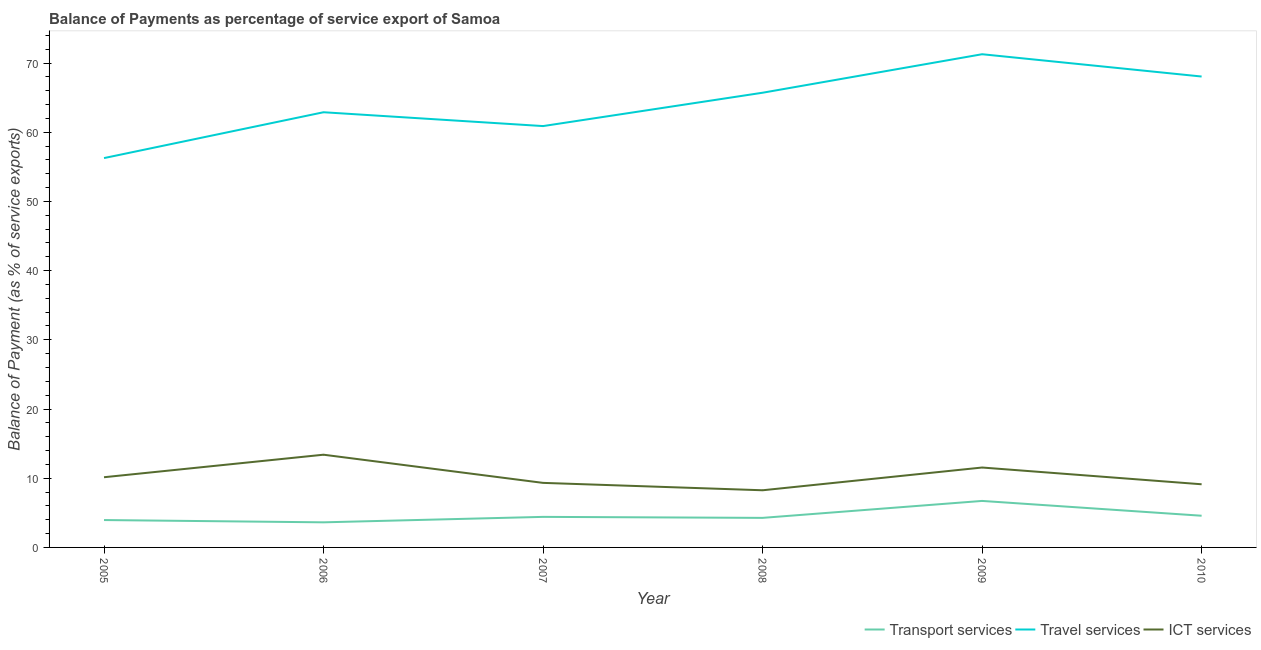Does the line corresponding to balance of payment of transport services intersect with the line corresponding to balance of payment of travel services?
Make the answer very short. No. What is the balance of payment of travel services in 2008?
Your response must be concise. 65.71. Across all years, what is the maximum balance of payment of transport services?
Give a very brief answer. 6.72. Across all years, what is the minimum balance of payment of ict services?
Ensure brevity in your answer.  8.26. In which year was the balance of payment of transport services maximum?
Provide a short and direct response. 2009. In which year was the balance of payment of transport services minimum?
Provide a succinct answer. 2006. What is the total balance of payment of travel services in the graph?
Provide a succinct answer. 385.05. What is the difference between the balance of payment of ict services in 2008 and that in 2010?
Your answer should be compact. -0.87. What is the difference between the balance of payment of travel services in 2010 and the balance of payment of transport services in 2009?
Provide a short and direct response. 61.33. What is the average balance of payment of transport services per year?
Provide a succinct answer. 4.59. In the year 2006, what is the difference between the balance of payment of ict services and balance of payment of travel services?
Give a very brief answer. -49.49. What is the ratio of the balance of payment of ict services in 2008 to that in 2009?
Offer a terse response. 0.72. What is the difference between the highest and the second highest balance of payment of travel services?
Give a very brief answer. 3.22. What is the difference between the highest and the lowest balance of payment of transport services?
Your answer should be compact. 3.09. In how many years, is the balance of payment of ict services greater than the average balance of payment of ict services taken over all years?
Provide a short and direct response. 2. Is the sum of the balance of payment of transport services in 2006 and 2009 greater than the maximum balance of payment of travel services across all years?
Keep it short and to the point. No. Is it the case that in every year, the sum of the balance of payment of transport services and balance of payment of travel services is greater than the balance of payment of ict services?
Your response must be concise. Yes. Does the balance of payment of transport services monotonically increase over the years?
Make the answer very short. No. Is the balance of payment of travel services strictly less than the balance of payment of ict services over the years?
Your answer should be very brief. No. How many lines are there?
Provide a short and direct response. 3. Are the values on the major ticks of Y-axis written in scientific E-notation?
Give a very brief answer. No. What is the title of the graph?
Your answer should be compact. Balance of Payments as percentage of service export of Samoa. What is the label or title of the Y-axis?
Provide a succinct answer. Balance of Payment (as % of service exports). What is the Balance of Payment (as % of service exports) of Transport services in 2005?
Provide a short and direct response. 3.96. What is the Balance of Payment (as % of service exports) of Travel services in 2005?
Your response must be concise. 56.26. What is the Balance of Payment (as % of service exports) in ICT services in 2005?
Make the answer very short. 10.14. What is the Balance of Payment (as % of service exports) in Transport services in 2006?
Offer a terse response. 3.63. What is the Balance of Payment (as % of service exports) of Travel services in 2006?
Your answer should be very brief. 62.88. What is the Balance of Payment (as % of service exports) of ICT services in 2006?
Offer a very short reply. 13.4. What is the Balance of Payment (as % of service exports) of Transport services in 2007?
Your answer should be compact. 4.41. What is the Balance of Payment (as % of service exports) in Travel services in 2007?
Your response must be concise. 60.89. What is the Balance of Payment (as % of service exports) in ICT services in 2007?
Your answer should be very brief. 9.33. What is the Balance of Payment (as % of service exports) of Transport services in 2008?
Provide a succinct answer. 4.27. What is the Balance of Payment (as % of service exports) of Travel services in 2008?
Offer a terse response. 65.71. What is the Balance of Payment (as % of service exports) in ICT services in 2008?
Provide a short and direct response. 8.26. What is the Balance of Payment (as % of service exports) of Transport services in 2009?
Give a very brief answer. 6.72. What is the Balance of Payment (as % of service exports) of Travel services in 2009?
Provide a succinct answer. 71.27. What is the Balance of Payment (as % of service exports) of ICT services in 2009?
Your response must be concise. 11.55. What is the Balance of Payment (as % of service exports) of Transport services in 2010?
Provide a short and direct response. 4.58. What is the Balance of Payment (as % of service exports) of Travel services in 2010?
Provide a succinct answer. 68.05. What is the Balance of Payment (as % of service exports) in ICT services in 2010?
Provide a succinct answer. 9.13. Across all years, what is the maximum Balance of Payment (as % of service exports) of Transport services?
Your response must be concise. 6.72. Across all years, what is the maximum Balance of Payment (as % of service exports) of Travel services?
Give a very brief answer. 71.27. Across all years, what is the maximum Balance of Payment (as % of service exports) of ICT services?
Your answer should be very brief. 13.4. Across all years, what is the minimum Balance of Payment (as % of service exports) in Transport services?
Ensure brevity in your answer.  3.63. Across all years, what is the minimum Balance of Payment (as % of service exports) in Travel services?
Your response must be concise. 56.26. Across all years, what is the minimum Balance of Payment (as % of service exports) of ICT services?
Your answer should be compact. 8.26. What is the total Balance of Payment (as % of service exports) of Transport services in the graph?
Provide a short and direct response. 27.57. What is the total Balance of Payment (as % of service exports) of Travel services in the graph?
Offer a very short reply. 385.05. What is the total Balance of Payment (as % of service exports) in ICT services in the graph?
Offer a terse response. 61.8. What is the difference between the Balance of Payment (as % of service exports) of Transport services in 2005 and that in 2006?
Your answer should be very brief. 0.33. What is the difference between the Balance of Payment (as % of service exports) of Travel services in 2005 and that in 2006?
Make the answer very short. -6.62. What is the difference between the Balance of Payment (as % of service exports) in ICT services in 2005 and that in 2006?
Your answer should be very brief. -3.25. What is the difference between the Balance of Payment (as % of service exports) in Transport services in 2005 and that in 2007?
Keep it short and to the point. -0.46. What is the difference between the Balance of Payment (as % of service exports) in Travel services in 2005 and that in 2007?
Provide a succinct answer. -4.63. What is the difference between the Balance of Payment (as % of service exports) of ICT services in 2005 and that in 2007?
Your answer should be compact. 0.82. What is the difference between the Balance of Payment (as % of service exports) in Transport services in 2005 and that in 2008?
Offer a terse response. -0.32. What is the difference between the Balance of Payment (as % of service exports) of Travel services in 2005 and that in 2008?
Give a very brief answer. -9.45. What is the difference between the Balance of Payment (as % of service exports) of ICT services in 2005 and that in 2008?
Your answer should be compact. 1.88. What is the difference between the Balance of Payment (as % of service exports) of Transport services in 2005 and that in 2009?
Your answer should be very brief. -2.76. What is the difference between the Balance of Payment (as % of service exports) in Travel services in 2005 and that in 2009?
Provide a short and direct response. -15.01. What is the difference between the Balance of Payment (as % of service exports) in ICT services in 2005 and that in 2009?
Ensure brevity in your answer.  -1.4. What is the difference between the Balance of Payment (as % of service exports) of Transport services in 2005 and that in 2010?
Give a very brief answer. -0.62. What is the difference between the Balance of Payment (as % of service exports) of Travel services in 2005 and that in 2010?
Offer a terse response. -11.79. What is the difference between the Balance of Payment (as % of service exports) in ICT services in 2005 and that in 2010?
Give a very brief answer. 1.02. What is the difference between the Balance of Payment (as % of service exports) of Transport services in 2006 and that in 2007?
Your response must be concise. -0.79. What is the difference between the Balance of Payment (as % of service exports) in Travel services in 2006 and that in 2007?
Give a very brief answer. 2. What is the difference between the Balance of Payment (as % of service exports) of ICT services in 2006 and that in 2007?
Offer a terse response. 4.07. What is the difference between the Balance of Payment (as % of service exports) in Transport services in 2006 and that in 2008?
Your answer should be very brief. -0.65. What is the difference between the Balance of Payment (as % of service exports) in Travel services in 2006 and that in 2008?
Provide a short and direct response. -2.82. What is the difference between the Balance of Payment (as % of service exports) of ICT services in 2006 and that in 2008?
Make the answer very short. 5.14. What is the difference between the Balance of Payment (as % of service exports) of Transport services in 2006 and that in 2009?
Your response must be concise. -3.09. What is the difference between the Balance of Payment (as % of service exports) of Travel services in 2006 and that in 2009?
Give a very brief answer. -8.38. What is the difference between the Balance of Payment (as % of service exports) of ICT services in 2006 and that in 2009?
Offer a terse response. 1.85. What is the difference between the Balance of Payment (as % of service exports) in Transport services in 2006 and that in 2010?
Provide a succinct answer. -0.95. What is the difference between the Balance of Payment (as % of service exports) of Travel services in 2006 and that in 2010?
Make the answer very short. -5.16. What is the difference between the Balance of Payment (as % of service exports) in ICT services in 2006 and that in 2010?
Your answer should be very brief. 4.27. What is the difference between the Balance of Payment (as % of service exports) in Transport services in 2007 and that in 2008?
Keep it short and to the point. 0.14. What is the difference between the Balance of Payment (as % of service exports) in Travel services in 2007 and that in 2008?
Ensure brevity in your answer.  -4.82. What is the difference between the Balance of Payment (as % of service exports) of ICT services in 2007 and that in 2008?
Your answer should be very brief. 1.07. What is the difference between the Balance of Payment (as % of service exports) in Transport services in 2007 and that in 2009?
Offer a very short reply. -2.31. What is the difference between the Balance of Payment (as % of service exports) of Travel services in 2007 and that in 2009?
Your answer should be compact. -10.38. What is the difference between the Balance of Payment (as % of service exports) of ICT services in 2007 and that in 2009?
Keep it short and to the point. -2.22. What is the difference between the Balance of Payment (as % of service exports) of Transport services in 2007 and that in 2010?
Provide a succinct answer. -0.17. What is the difference between the Balance of Payment (as % of service exports) in Travel services in 2007 and that in 2010?
Your answer should be very brief. -7.16. What is the difference between the Balance of Payment (as % of service exports) of ICT services in 2007 and that in 2010?
Keep it short and to the point. 0.2. What is the difference between the Balance of Payment (as % of service exports) of Transport services in 2008 and that in 2009?
Offer a very short reply. -2.45. What is the difference between the Balance of Payment (as % of service exports) in Travel services in 2008 and that in 2009?
Your answer should be very brief. -5.56. What is the difference between the Balance of Payment (as % of service exports) of ICT services in 2008 and that in 2009?
Make the answer very short. -3.29. What is the difference between the Balance of Payment (as % of service exports) of Transport services in 2008 and that in 2010?
Provide a short and direct response. -0.31. What is the difference between the Balance of Payment (as % of service exports) of Travel services in 2008 and that in 2010?
Offer a terse response. -2.34. What is the difference between the Balance of Payment (as % of service exports) in ICT services in 2008 and that in 2010?
Provide a succinct answer. -0.87. What is the difference between the Balance of Payment (as % of service exports) in Transport services in 2009 and that in 2010?
Offer a terse response. 2.14. What is the difference between the Balance of Payment (as % of service exports) in Travel services in 2009 and that in 2010?
Your answer should be very brief. 3.22. What is the difference between the Balance of Payment (as % of service exports) in ICT services in 2009 and that in 2010?
Provide a short and direct response. 2.42. What is the difference between the Balance of Payment (as % of service exports) in Transport services in 2005 and the Balance of Payment (as % of service exports) in Travel services in 2006?
Make the answer very short. -58.93. What is the difference between the Balance of Payment (as % of service exports) in Transport services in 2005 and the Balance of Payment (as % of service exports) in ICT services in 2006?
Ensure brevity in your answer.  -9.44. What is the difference between the Balance of Payment (as % of service exports) of Travel services in 2005 and the Balance of Payment (as % of service exports) of ICT services in 2006?
Your answer should be compact. 42.86. What is the difference between the Balance of Payment (as % of service exports) of Transport services in 2005 and the Balance of Payment (as % of service exports) of Travel services in 2007?
Keep it short and to the point. -56.93. What is the difference between the Balance of Payment (as % of service exports) of Transport services in 2005 and the Balance of Payment (as % of service exports) of ICT services in 2007?
Give a very brief answer. -5.37. What is the difference between the Balance of Payment (as % of service exports) of Travel services in 2005 and the Balance of Payment (as % of service exports) of ICT services in 2007?
Your answer should be compact. 46.93. What is the difference between the Balance of Payment (as % of service exports) in Transport services in 2005 and the Balance of Payment (as % of service exports) in Travel services in 2008?
Keep it short and to the point. -61.75. What is the difference between the Balance of Payment (as % of service exports) of Transport services in 2005 and the Balance of Payment (as % of service exports) of ICT services in 2008?
Your answer should be compact. -4.3. What is the difference between the Balance of Payment (as % of service exports) in Travel services in 2005 and the Balance of Payment (as % of service exports) in ICT services in 2008?
Your answer should be compact. 48. What is the difference between the Balance of Payment (as % of service exports) in Transport services in 2005 and the Balance of Payment (as % of service exports) in Travel services in 2009?
Your answer should be very brief. -67.31. What is the difference between the Balance of Payment (as % of service exports) of Transport services in 2005 and the Balance of Payment (as % of service exports) of ICT services in 2009?
Your response must be concise. -7.59. What is the difference between the Balance of Payment (as % of service exports) of Travel services in 2005 and the Balance of Payment (as % of service exports) of ICT services in 2009?
Make the answer very short. 44.71. What is the difference between the Balance of Payment (as % of service exports) of Transport services in 2005 and the Balance of Payment (as % of service exports) of Travel services in 2010?
Offer a terse response. -64.09. What is the difference between the Balance of Payment (as % of service exports) of Transport services in 2005 and the Balance of Payment (as % of service exports) of ICT services in 2010?
Offer a very short reply. -5.17. What is the difference between the Balance of Payment (as % of service exports) in Travel services in 2005 and the Balance of Payment (as % of service exports) in ICT services in 2010?
Give a very brief answer. 47.13. What is the difference between the Balance of Payment (as % of service exports) of Transport services in 2006 and the Balance of Payment (as % of service exports) of Travel services in 2007?
Make the answer very short. -57.26. What is the difference between the Balance of Payment (as % of service exports) in Transport services in 2006 and the Balance of Payment (as % of service exports) in ICT services in 2007?
Ensure brevity in your answer.  -5.7. What is the difference between the Balance of Payment (as % of service exports) in Travel services in 2006 and the Balance of Payment (as % of service exports) in ICT services in 2007?
Offer a very short reply. 53.56. What is the difference between the Balance of Payment (as % of service exports) in Transport services in 2006 and the Balance of Payment (as % of service exports) in Travel services in 2008?
Offer a terse response. -62.08. What is the difference between the Balance of Payment (as % of service exports) of Transport services in 2006 and the Balance of Payment (as % of service exports) of ICT services in 2008?
Your answer should be very brief. -4.63. What is the difference between the Balance of Payment (as % of service exports) in Travel services in 2006 and the Balance of Payment (as % of service exports) in ICT services in 2008?
Your response must be concise. 54.63. What is the difference between the Balance of Payment (as % of service exports) of Transport services in 2006 and the Balance of Payment (as % of service exports) of Travel services in 2009?
Provide a short and direct response. -67.64. What is the difference between the Balance of Payment (as % of service exports) of Transport services in 2006 and the Balance of Payment (as % of service exports) of ICT services in 2009?
Make the answer very short. -7.92. What is the difference between the Balance of Payment (as % of service exports) of Travel services in 2006 and the Balance of Payment (as % of service exports) of ICT services in 2009?
Your answer should be compact. 51.34. What is the difference between the Balance of Payment (as % of service exports) of Transport services in 2006 and the Balance of Payment (as % of service exports) of Travel services in 2010?
Ensure brevity in your answer.  -64.42. What is the difference between the Balance of Payment (as % of service exports) in Transport services in 2006 and the Balance of Payment (as % of service exports) in ICT services in 2010?
Ensure brevity in your answer.  -5.5. What is the difference between the Balance of Payment (as % of service exports) of Travel services in 2006 and the Balance of Payment (as % of service exports) of ICT services in 2010?
Make the answer very short. 53.76. What is the difference between the Balance of Payment (as % of service exports) in Transport services in 2007 and the Balance of Payment (as % of service exports) in Travel services in 2008?
Your answer should be very brief. -61.29. What is the difference between the Balance of Payment (as % of service exports) of Transport services in 2007 and the Balance of Payment (as % of service exports) of ICT services in 2008?
Your response must be concise. -3.85. What is the difference between the Balance of Payment (as % of service exports) of Travel services in 2007 and the Balance of Payment (as % of service exports) of ICT services in 2008?
Offer a very short reply. 52.63. What is the difference between the Balance of Payment (as % of service exports) of Transport services in 2007 and the Balance of Payment (as % of service exports) of Travel services in 2009?
Ensure brevity in your answer.  -66.85. What is the difference between the Balance of Payment (as % of service exports) in Transport services in 2007 and the Balance of Payment (as % of service exports) in ICT services in 2009?
Ensure brevity in your answer.  -7.13. What is the difference between the Balance of Payment (as % of service exports) of Travel services in 2007 and the Balance of Payment (as % of service exports) of ICT services in 2009?
Your answer should be very brief. 49.34. What is the difference between the Balance of Payment (as % of service exports) of Transport services in 2007 and the Balance of Payment (as % of service exports) of Travel services in 2010?
Provide a short and direct response. -63.63. What is the difference between the Balance of Payment (as % of service exports) of Transport services in 2007 and the Balance of Payment (as % of service exports) of ICT services in 2010?
Offer a terse response. -4.71. What is the difference between the Balance of Payment (as % of service exports) of Travel services in 2007 and the Balance of Payment (as % of service exports) of ICT services in 2010?
Your answer should be very brief. 51.76. What is the difference between the Balance of Payment (as % of service exports) in Transport services in 2008 and the Balance of Payment (as % of service exports) in Travel services in 2009?
Ensure brevity in your answer.  -67. What is the difference between the Balance of Payment (as % of service exports) of Transport services in 2008 and the Balance of Payment (as % of service exports) of ICT services in 2009?
Your answer should be compact. -7.28. What is the difference between the Balance of Payment (as % of service exports) in Travel services in 2008 and the Balance of Payment (as % of service exports) in ICT services in 2009?
Provide a succinct answer. 54.16. What is the difference between the Balance of Payment (as % of service exports) of Transport services in 2008 and the Balance of Payment (as % of service exports) of Travel services in 2010?
Give a very brief answer. -63.78. What is the difference between the Balance of Payment (as % of service exports) of Transport services in 2008 and the Balance of Payment (as % of service exports) of ICT services in 2010?
Your response must be concise. -4.85. What is the difference between the Balance of Payment (as % of service exports) of Travel services in 2008 and the Balance of Payment (as % of service exports) of ICT services in 2010?
Offer a terse response. 56.58. What is the difference between the Balance of Payment (as % of service exports) of Transport services in 2009 and the Balance of Payment (as % of service exports) of Travel services in 2010?
Provide a short and direct response. -61.33. What is the difference between the Balance of Payment (as % of service exports) of Transport services in 2009 and the Balance of Payment (as % of service exports) of ICT services in 2010?
Your answer should be very brief. -2.41. What is the difference between the Balance of Payment (as % of service exports) in Travel services in 2009 and the Balance of Payment (as % of service exports) in ICT services in 2010?
Your response must be concise. 62.14. What is the average Balance of Payment (as % of service exports) in Transport services per year?
Offer a very short reply. 4.59. What is the average Balance of Payment (as % of service exports) of Travel services per year?
Provide a short and direct response. 64.18. What is the average Balance of Payment (as % of service exports) of ICT services per year?
Your answer should be very brief. 10.3. In the year 2005, what is the difference between the Balance of Payment (as % of service exports) in Transport services and Balance of Payment (as % of service exports) in Travel services?
Keep it short and to the point. -52.3. In the year 2005, what is the difference between the Balance of Payment (as % of service exports) in Transport services and Balance of Payment (as % of service exports) in ICT services?
Make the answer very short. -6.19. In the year 2005, what is the difference between the Balance of Payment (as % of service exports) of Travel services and Balance of Payment (as % of service exports) of ICT services?
Make the answer very short. 46.12. In the year 2006, what is the difference between the Balance of Payment (as % of service exports) of Transport services and Balance of Payment (as % of service exports) of Travel services?
Keep it short and to the point. -59.26. In the year 2006, what is the difference between the Balance of Payment (as % of service exports) of Transport services and Balance of Payment (as % of service exports) of ICT services?
Provide a short and direct response. -9.77. In the year 2006, what is the difference between the Balance of Payment (as % of service exports) of Travel services and Balance of Payment (as % of service exports) of ICT services?
Keep it short and to the point. 49.49. In the year 2007, what is the difference between the Balance of Payment (as % of service exports) of Transport services and Balance of Payment (as % of service exports) of Travel services?
Your response must be concise. -56.47. In the year 2007, what is the difference between the Balance of Payment (as % of service exports) of Transport services and Balance of Payment (as % of service exports) of ICT services?
Your answer should be very brief. -4.91. In the year 2007, what is the difference between the Balance of Payment (as % of service exports) of Travel services and Balance of Payment (as % of service exports) of ICT services?
Offer a very short reply. 51.56. In the year 2008, what is the difference between the Balance of Payment (as % of service exports) of Transport services and Balance of Payment (as % of service exports) of Travel services?
Your answer should be very brief. -61.43. In the year 2008, what is the difference between the Balance of Payment (as % of service exports) of Transport services and Balance of Payment (as % of service exports) of ICT services?
Make the answer very short. -3.99. In the year 2008, what is the difference between the Balance of Payment (as % of service exports) of Travel services and Balance of Payment (as % of service exports) of ICT services?
Provide a succinct answer. 57.45. In the year 2009, what is the difference between the Balance of Payment (as % of service exports) of Transport services and Balance of Payment (as % of service exports) of Travel services?
Offer a very short reply. -64.55. In the year 2009, what is the difference between the Balance of Payment (as % of service exports) of Transport services and Balance of Payment (as % of service exports) of ICT services?
Provide a succinct answer. -4.83. In the year 2009, what is the difference between the Balance of Payment (as % of service exports) in Travel services and Balance of Payment (as % of service exports) in ICT services?
Give a very brief answer. 59.72. In the year 2010, what is the difference between the Balance of Payment (as % of service exports) of Transport services and Balance of Payment (as % of service exports) of Travel services?
Your response must be concise. -63.47. In the year 2010, what is the difference between the Balance of Payment (as % of service exports) of Transport services and Balance of Payment (as % of service exports) of ICT services?
Give a very brief answer. -4.55. In the year 2010, what is the difference between the Balance of Payment (as % of service exports) of Travel services and Balance of Payment (as % of service exports) of ICT services?
Provide a short and direct response. 58.92. What is the ratio of the Balance of Payment (as % of service exports) of Transport services in 2005 to that in 2006?
Your answer should be very brief. 1.09. What is the ratio of the Balance of Payment (as % of service exports) of Travel services in 2005 to that in 2006?
Keep it short and to the point. 0.89. What is the ratio of the Balance of Payment (as % of service exports) in ICT services in 2005 to that in 2006?
Keep it short and to the point. 0.76. What is the ratio of the Balance of Payment (as % of service exports) of Transport services in 2005 to that in 2007?
Your answer should be compact. 0.9. What is the ratio of the Balance of Payment (as % of service exports) in Travel services in 2005 to that in 2007?
Give a very brief answer. 0.92. What is the ratio of the Balance of Payment (as % of service exports) in ICT services in 2005 to that in 2007?
Ensure brevity in your answer.  1.09. What is the ratio of the Balance of Payment (as % of service exports) of Transport services in 2005 to that in 2008?
Your response must be concise. 0.93. What is the ratio of the Balance of Payment (as % of service exports) in Travel services in 2005 to that in 2008?
Give a very brief answer. 0.86. What is the ratio of the Balance of Payment (as % of service exports) of ICT services in 2005 to that in 2008?
Provide a succinct answer. 1.23. What is the ratio of the Balance of Payment (as % of service exports) of Transport services in 2005 to that in 2009?
Keep it short and to the point. 0.59. What is the ratio of the Balance of Payment (as % of service exports) of Travel services in 2005 to that in 2009?
Offer a very short reply. 0.79. What is the ratio of the Balance of Payment (as % of service exports) of ICT services in 2005 to that in 2009?
Your answer should be compact. 0.88. What is the ratio of the Balance of Payment (as % of service exports) of Transport services in 2005 to that in 2010?
Offer a terse response. 0.86. What is the ratio of the Balance of Payment (as % of service exports) of Travel services in 2005 to that in 2010?
Offer a terse response. 0.83. What is the ratio of the Balance of Payment (as % of service exports) in ICT services in 2005 to that in 2010?
Make the answer very short. 1.11. What is the ratio of the Balance of Payment (as % of service exports) in Transport services in 2006 to that in 2007?
Ensure brevity in your answer.  0.82. What is the ratio of the Balance of Payment (as % of service exports) of Travel services in 2006 to that in 2007?
Your answer should be compact. 1.03. What is the ratio of the Balance of Payment (as % of service exports) in ICT services in 2006 to that in 2007?
Keep it short and to the point. 1.44. What is the ratio of the Balance of Payment (as % of service exports) in Transport services in 2006 to that in 2008?
Make the answer very short. 0.85. What is the ratio of the Balance of Payment (as % of service exports) in Travel services in 2006 to that in 2008?
Give a very brief answer. 0.96. What is the ratio of the Balance of Payment (as % of service exports) of ICT services in 2006 to that in 2008?
Offer a terse response. 1.62. What is the ratio of the Balance of Payment (as % of service exports) in Transport services in 2006 to that in 2009?
Ensure brevity in your answer.  0.54. What is the ratio of the Balance of Payment (as % of service exports) in Travel services in 2006 to that in 2009?
Keep it short and to the point. 0.88. What is the ratio of the Balance of Payment (as % of service exports) in ICT services in 2006 to that in 2009?
Make the answer very short. 1.16. What is the ratio of the Balance of Payment (as % of service exports) in Transport services in 2006 to that in 2010?
Your answer should be compact. 0.79. What is the ratio of the Balance of Payment (as % of service exports) in Travel services in 2006 to that in 2010?
Provide a short and direct response. 0.92. What is the ratio of the Balance of Payment (as % of service exports) of ICT services in 2006 to that in 2010?
Make the answer very short. 1.47. What is the ratio of the Balance of Payment (as % of service exports) in Transport services in 2007 to that in 2008?
Your response must be concise. 1.03. What is the ratio of the Balance of Payment (as % of service exports) of Travel services in 2007 to that in 2008?
Offer a terse response. 0.93. What is the ratio of the Balance of Payment (as % of service exports) of ICT services in 2007 to that in 2008?
Keep it short and to the point. 1.13. What is the ratio of the Balance of Payment (as % of service exports) in Transport services in 2007 to that in 2009?
Ensure brevity in your answer.  0.66. What is the ratio of the Balance of Payment (as % of service exports) of Travel services in 2007 to that in 2009?
Offer a very short reply. 0.85. What is the ratio of the Balance of Payment (as % of service exports) of ICT services in 2007 to that in 2009?
Your answer should be compact. 0.81. What is the ratio of the Balance of Payment (as % of service exports) of Transport services in 2007 to that in 2010?
Provide a succinct answer. 0.96. What is the ratio of the Balance of Payment (as % of service exports) of Travel services in 2007 to that in 2010?
Your answer should be very brief. 0.89. What is the ratio of the Balance of Payment (as % of service exports) of ICT services in 2007 to that in 2010?
Offer a very short reply. 1.02. What is the ratio of the Balance of Payment (as % of service exports) of Transport services in 2008 to that in 2009?
Ensure brevity in your answer.  0.64. What is the ratio of the Balance of Payment (as % of service exports) of Travel services in 2008 to that in 2009?
Your response must be concise. 0.92. What is the ratio of the Balance of Payment (as % of service exports) of ICT services in 2008 to that in 2009?
Your response must be concise. 0.72. What is the ratio of the Balance of Payment (as % of service exports) of Transport services in 2008 to that in 2010?
Provide a succinct answer. 0.93. What is the ratio of the Balance of Payment (as % of service exports) of Travel services in 2008 to that in 2010?
Provide a short and direct response. 0.97. What is the ratio of the Balance of Payment (as % of service exports) of ICT services in 2008 to that in 2010?
Your response must be concise. 0.91. What is the ratio of the Balance of Payment (as % of service exports) in Transport services in 2009 to that in 2010?
Offer a very short reply. 1.47. What is the ratio of the Balance of Payment (as % of service exports) of Travel services in 2009 to that in 2010?
Keep it short and to the point. 1.05. What is the ratio of the Balance of Payment (as % of service exports) of ICT services in 2009 to that in 2010?
Ensure brevity in your answer.  1.27. What is the difference between the highest and the second highest Balance of Payment (as % of service exports) of Transport services?
Offer a very short reply. 2.14. What is the difference between the highest and the second highest Balance of Payment (as % of service exports) in Travel services?
Give a very brief answer. 3.22. What is the difference between the highest and the second highest Balance of Payment (as % of service exports) of ICT services?
Provide a short and direct response. 1.85. What is the difference between the highest and the lowest Balance of Payment (as % of service exports) in Transport services?
Offer a terse response. 3.09. What is the difference between the highest and the lowest Balance of Payment (as % of service exports) in Travel services?
Your answer should be compact. 15.01. What is the difference between the highest and the lowest Balance of Payment (as % of service exports) in ICT services?
Provide a short and direct response. 5.14. 